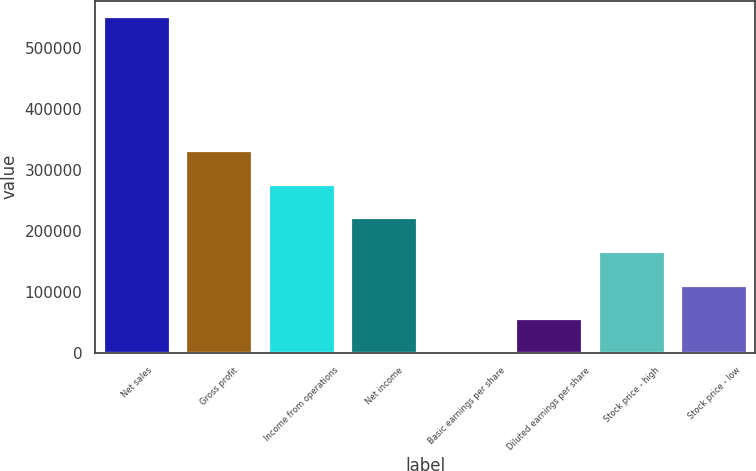<chart> <loc_0><loc_0><loc_500><loc_500><bar_chart><fcel>Net sales<fcel>Gross profit<fcel>Income from operations<fcel>Net income<fcel>Basic earnings per share<fcel>Diluted earnings per share<fcel>Stock price - high<fcel>Stock price - low<nl><fcel>550732<fcel>330439<fcel>275366<fcel>220293<fcel>0.19<fcel>55073.4<fcel>165220<fcel>110147<nl></chart> 